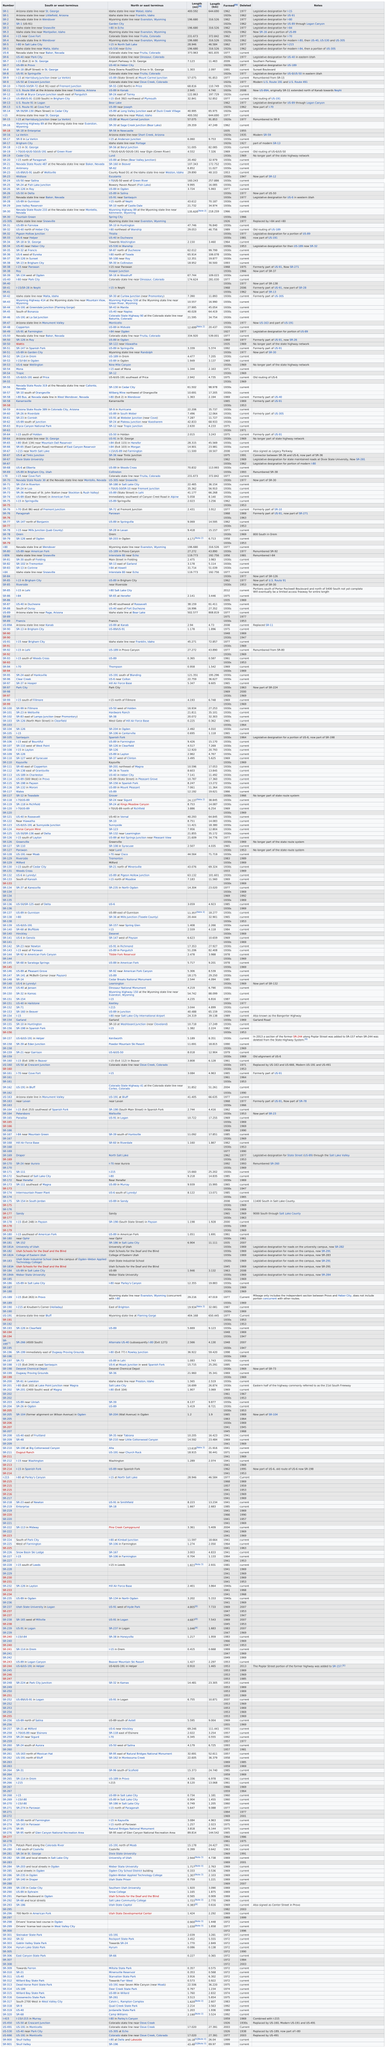Specify some key components in this picture. The number of miles that number sr-3 has is 196.680.... There is a highway located near Littlefield, Arizona. 